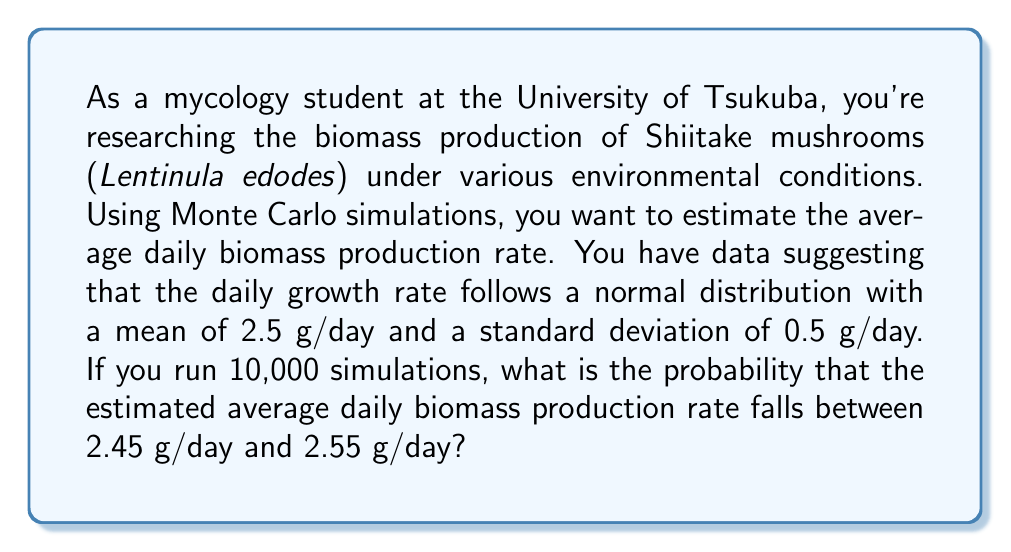Solve this math problem. To solve this problem, we'll follow these steps:

1) First, recall that the Monte Carlo method uses repeated random sampling to obtain numerical results. In this case, we're simulating daily growth rates.

2) The Central Limit Theorem states that for a large number of independent random variables, their sum (or average) will be approximately normally distributed, regardless of the underlying distribution.

3) Given:
   - Mean (μ) = 2.5 g/day
   - Standard deviation (σ) = 0.5 g/day
   - Number of simulations (n) = 10,000

4) The standard error of the mean (SEM) is given by:

   $$ SEM = \frac{\sigma}{\sqrt{n}} = \frac{0.5}{\sqrt{10000}} = 0.005 $$

5) The average of our simulations will be normally distributed with:
   - Mean = 2.5 g/day
   - Standard deviation = 0.005 g/day

6) We want to find the probability that this average falls between 2.45 and 2.55 g/day.

7) We can standardize these values:
   $$ z_{lower} = \frac{2.45 - 2.5}{0.005} = -10 $$
   $$ z_{upper} = \frac{2.55 - 2.5}{0.005} = 10 $$

8) The probability is the area between these z-scores on a standard normal distribution.

9) Using a standard normal table or calculator, we find:
   $$ P(-10 < Z < 10) = P(Z < 10) - P(Z < -10) $$
   $$ = 1 - 2 * P(Z < -10) $$
   $$ ≈ 1 - 2 * (7.62 * 10^{-24}) $$
   $$ ≈ 1 $$
Answer: $\approx 1$ or $99.9999999999999999999985\%$ 